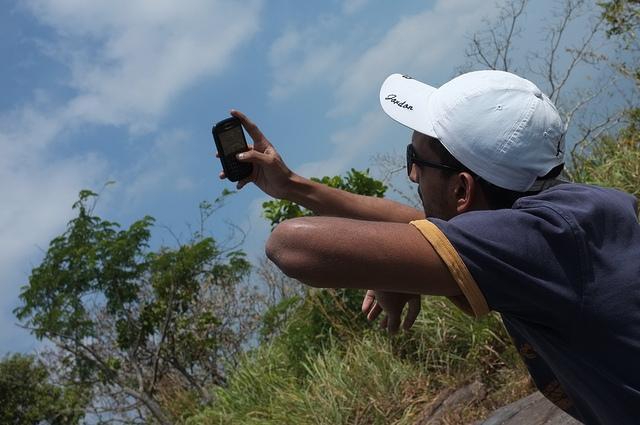How many spoons are on the counter?
Give a very brief answer. 0. 